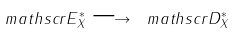<formula> <loc_0><loc_0><loc_500><loc_500>\ m a t h s c r { E } _ { X } ^ { \ast } \longrightarrow \ m a t h s c r { D } _ { X } ^ { \ast }</formula> 